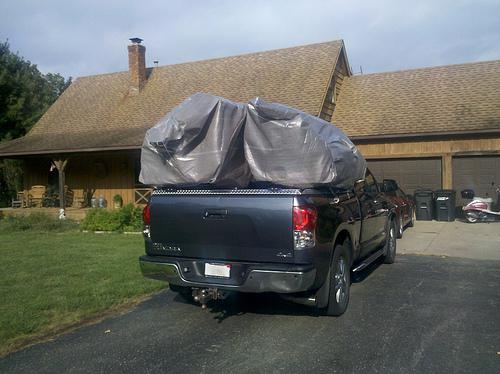Question: what color is the roof?
Choices:
A. Red.
B. Black.
C. Brown.
D. Gray.
Answer with the letter. Answer: C Question: what color are the garage doors?
Choices:
A. White.
B. Yellow.
C. Grey.
D. Brown.
Answer with the letter. Answer: C 